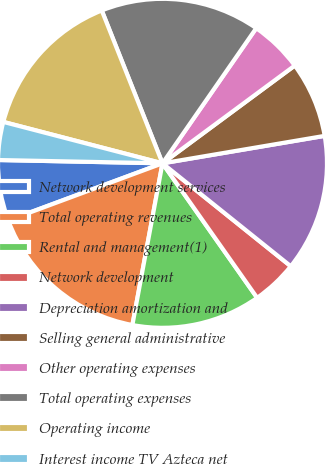<chart> <loc_0><loc_0><loc_500><loc_500><pie_chart><fcel>Network development services<fcel>Total operating revenues<fcel>Rental and management(1)<fcel>Network development<fcel>Depreciation amortization and<fcel>Selling general administrative<fcel>Other operating expenses<fcel>Total operating expenses<fcel>Operating income<fcel>Interest income TV Azteca net<nl><fcel>5.97%<fcel>16.42%<fcel>12.69%<fcel>4.48%<fcel>13.43%<fcel>7.46%<fcel>5.22%<fcel>15.67%<fcel>14.93%<fcel>3.73%<nl></chart> 